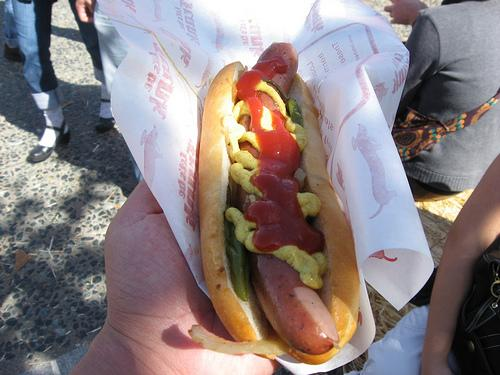Which ingredient contains the highest amount of sodium? Please explain your reasoning. sausage. The ingredient is sausage. 